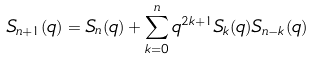<formula> <loc_0><loc_0><loc_500><loc_500>S _ { n + 1 } ( q ) = S _ { n } ( q ) + \sum _ { k = 0 } ^ { n } q ^ { 2 k + 1 } S _ { k } ( q ) S _ { n - k } ( q )</formula> 